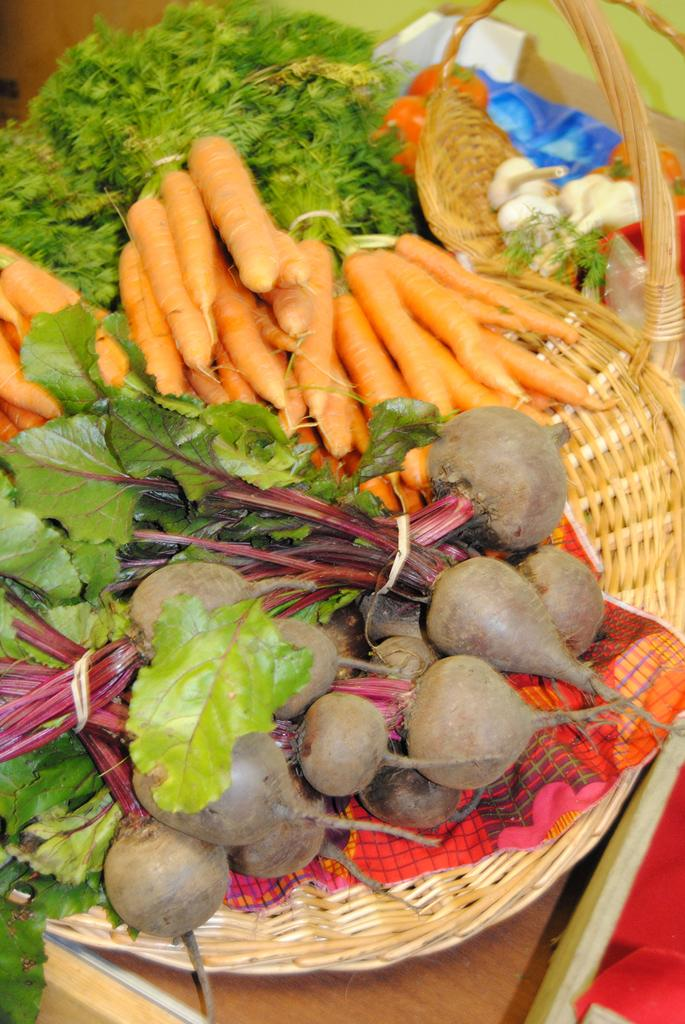What is located in the center of the image? There is a basket in the center of the image. What is inside the basket? The basket contains beetroots and carrots. Can you describe the other vegetables in the image? There are green leafy vegetables in the image. What type of answer can be seen written on the bat in the image? There is no bat present in the image, and therefore no answer can be seen written on it. 